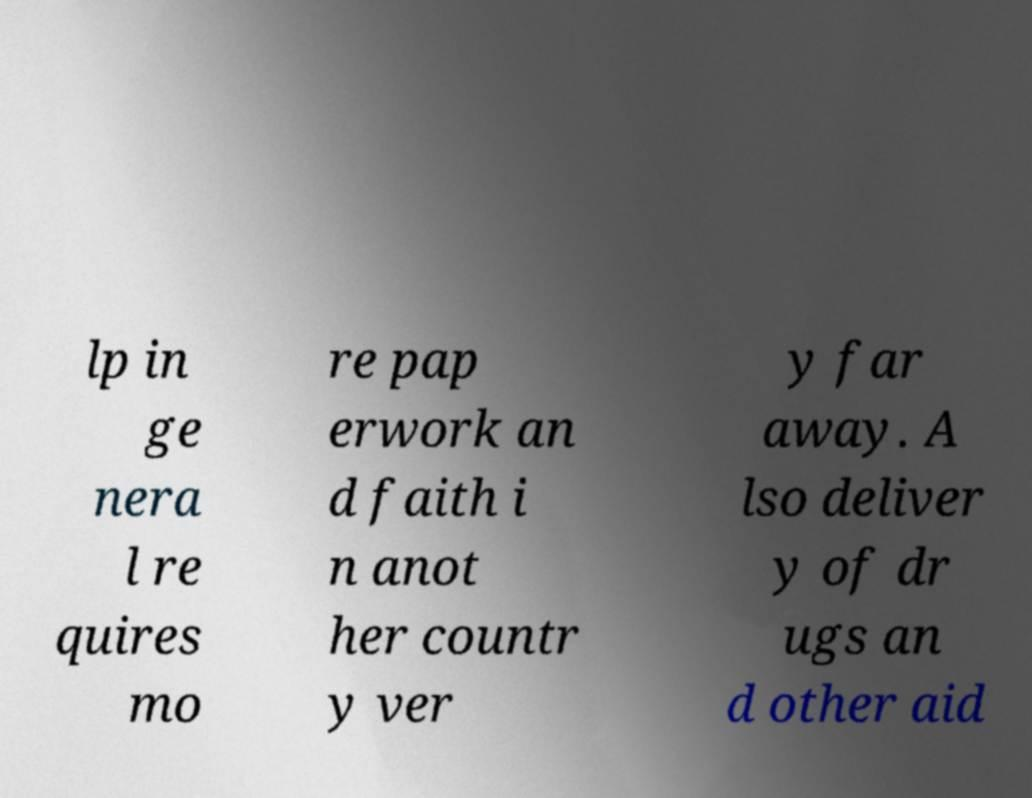Please read and relay the text visible in this image. What does it say? lp in ge nera l re quires mo re pap erwork an d faith i n anot her countr y ver y far away. A lso deliver y of dr ugs an d other aid 